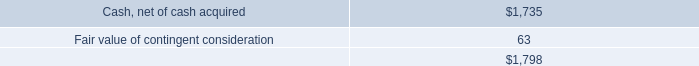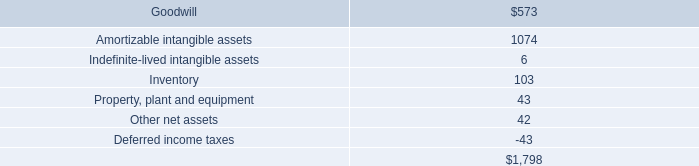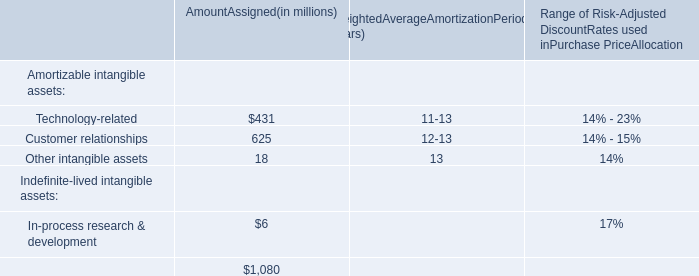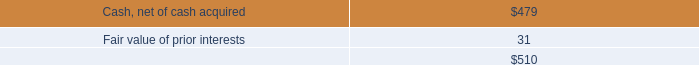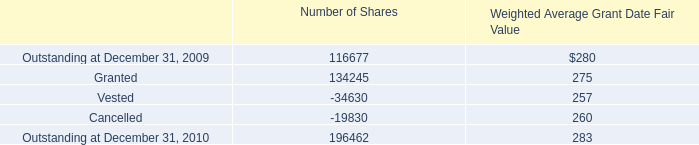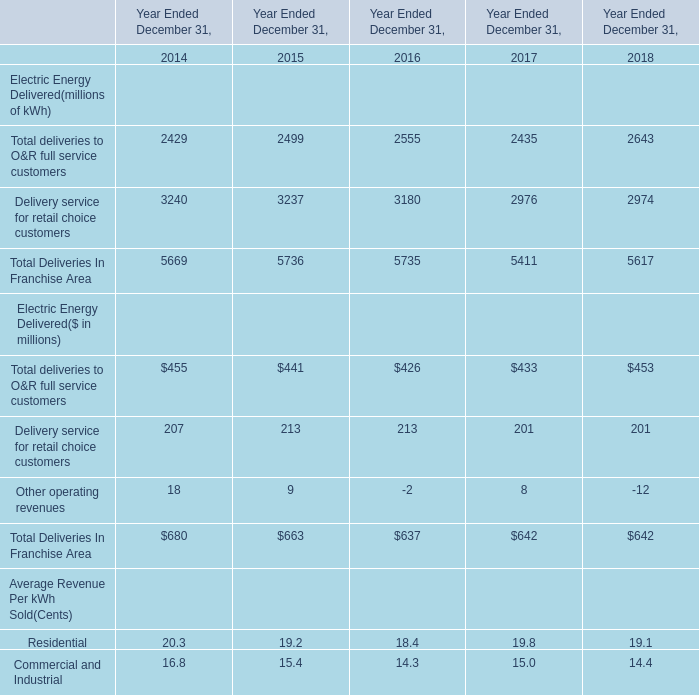What do all deliveries In Franchise Areasum up without those other operating revenues smaller than 600 in 2018? (in million) 
Computations: (453 + 201)
Answer: 654.0. 